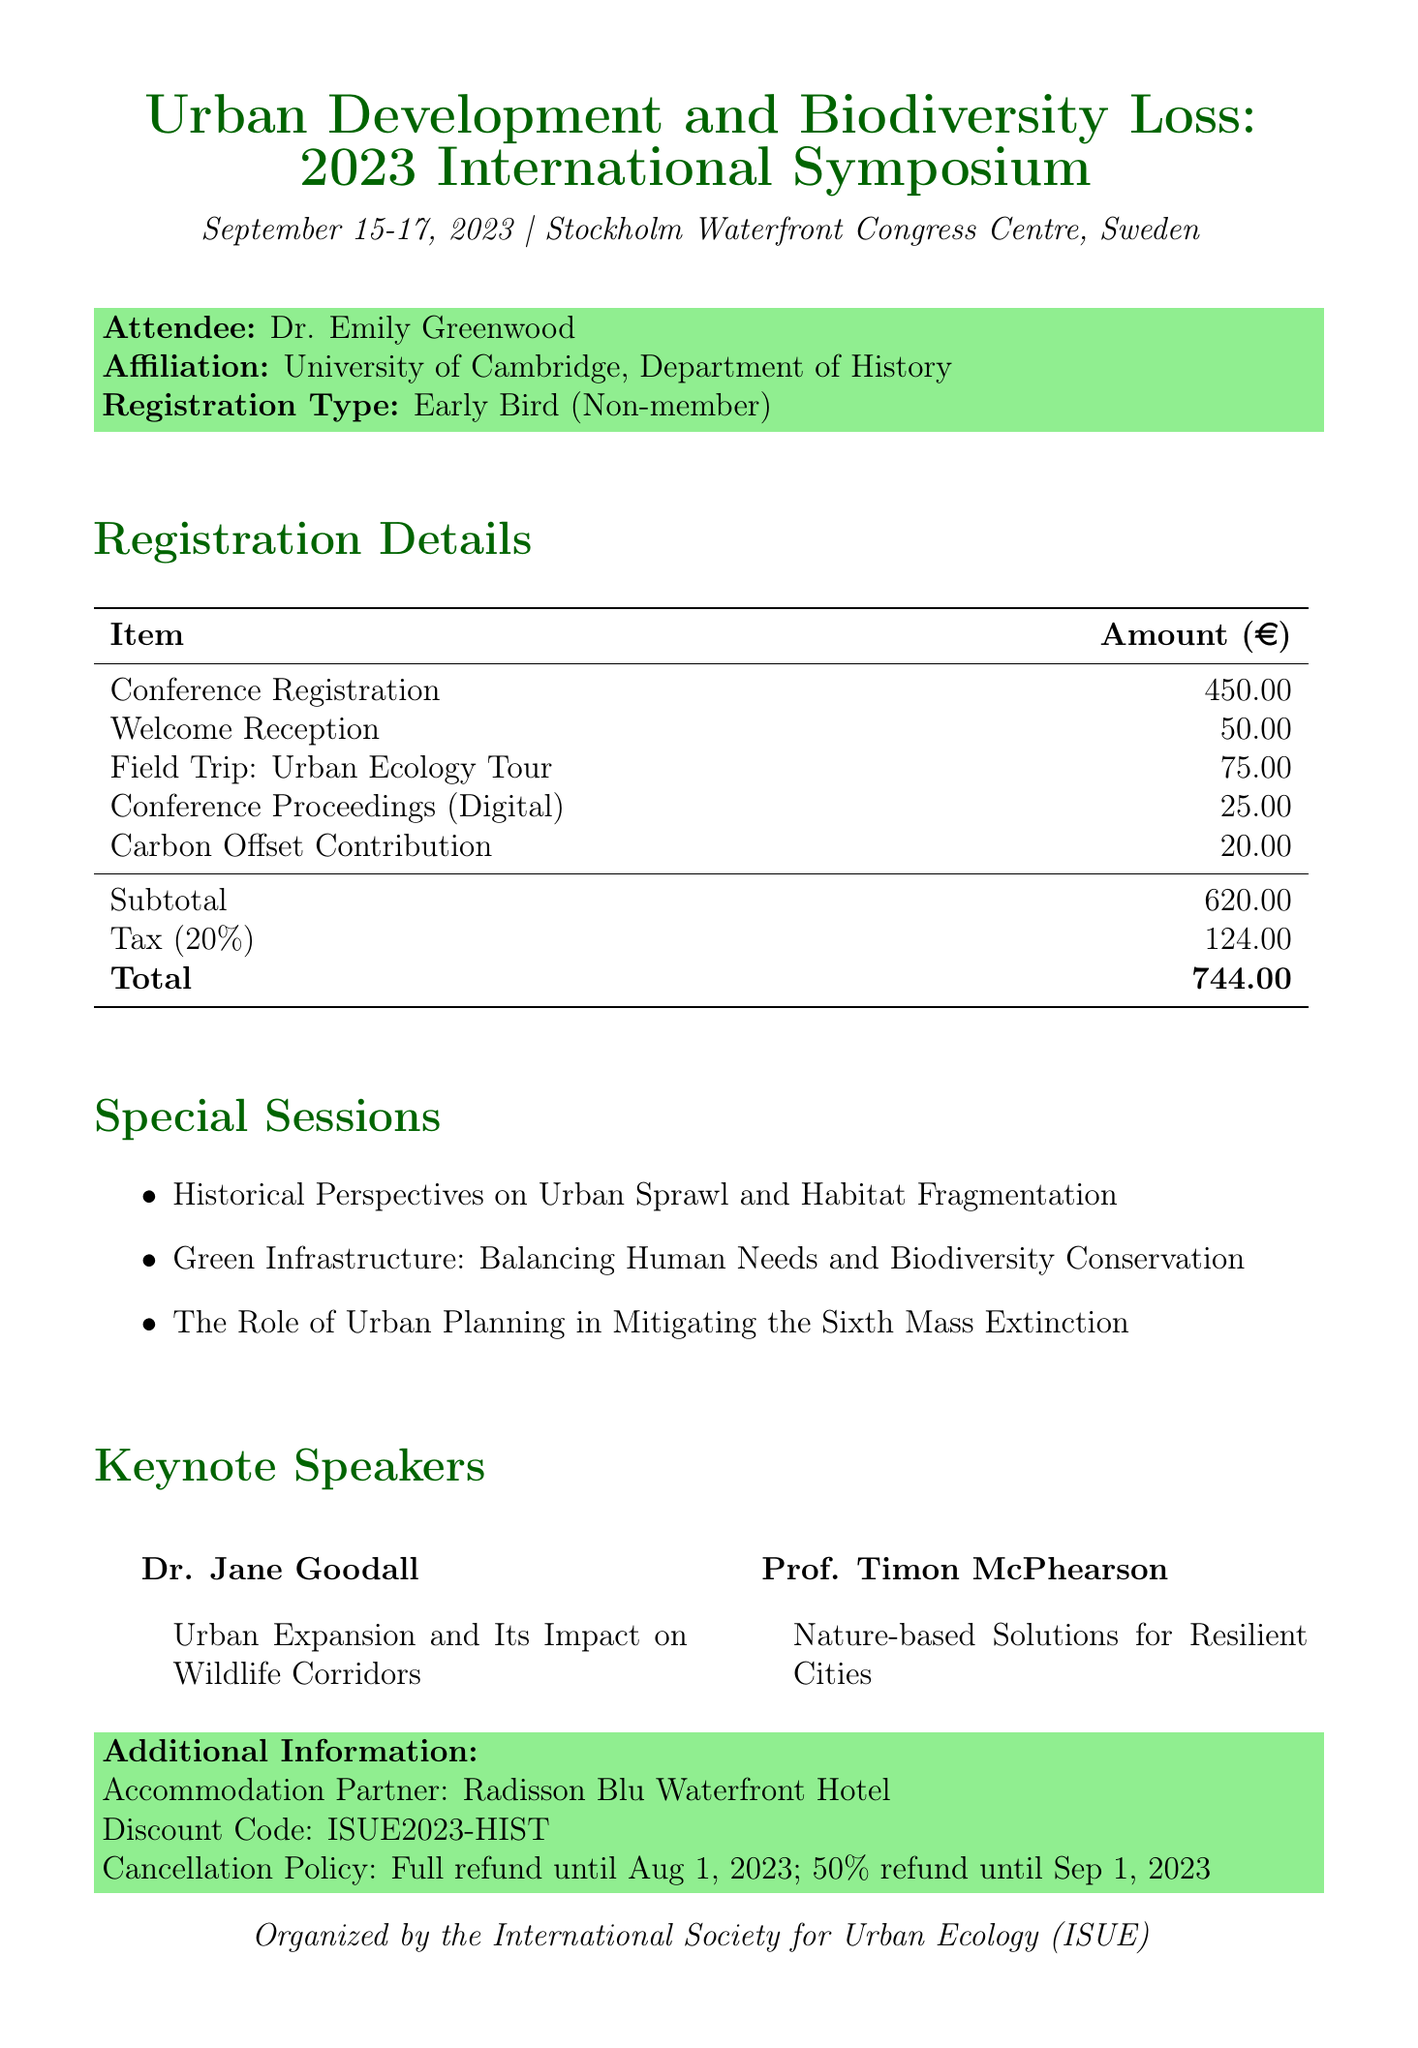What is the total amount due? The total amount due is provided in the payment details section of the document.
Answer: 744.00 Who is the attendee of the conference? The attendee's name is mentioned in the registration information section.
Answer: Dr. Emily Greenwood What is the date of the conference? The date of the conference is specified at the beginning of the document.
Answer: September 15-17, 2023 What is the subtotal before tax? The subtotal is listed in the payment details section as part of the breakdown.
Answer: 620.00 What type of registration did the attendee choose? The registration type is defined in the registration information section.
Answer: Early Bird What is the description for the Field Trip item? The description for the Field Trip is mentioned in the fee breakdown.
Answer: Urban Ecology Tour of Stockholm Royal National City Park What is the cancellation policy for the conference? The cancellation policy is provided in the additional information at the bottom of the document.
Answer: Full refund available until August 1, 2023; 50% refund until September 1, 2023 Who is one of the keynote speakers? The keynote speakers are listed in a dedicated section, including their names.
Answer: Dr. Jane Goodall How much is the Carbon Offset Contribution? The amount for the Carbon Offset Contribution is listed in the fee breakdown section.
Answer: 20.00 